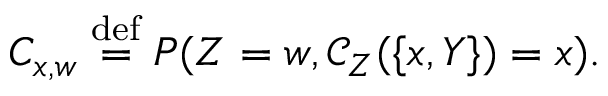Convert formula to latex. <formula><loc_0><loc_0><loc_500><loc_500>C _ { x , w } \stackrel { d e f } { = } P ( Z = w , \mathcal { C } _ { Z } ( \{ x , Y \} ) = x ) .</formula> 